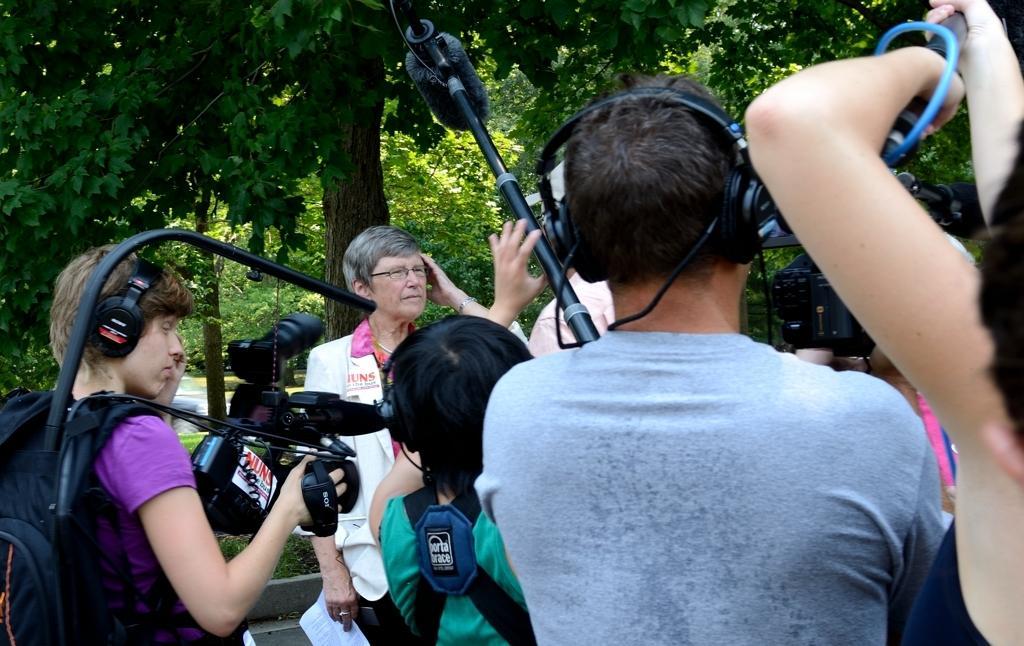Please provide a concise description of this image. Group of people standing and this person wore bag and holding camera and this person holding papers. Background we can see trees. 